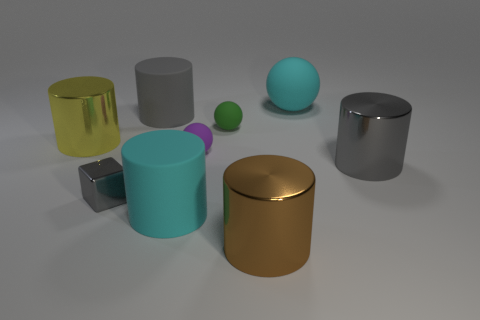The brown thing that is the same size as the yellow object is what shape?
Provide a short and direct response. Cylinder. Is the number of large gray rubber things less than the number of big yellow matte blocks?
Provide a succinct answer. No. There is a big cyan rubber thing that is in front of the cube; is there a tiny green sphere that is in front of it?
Your answer should be compact. No. There is a green thing that is the same material as the large sphere; what is its shape?
Make the answer very short. Sphere. Are there any other things that are the same color as the tiny shiny thing?
Provide a succinct answer. Yes. What material is the cyan thing that is the same shape as the green rubber object?
Your answer should be compact. Rubber. How many other objects are there of the same size as the yellow shiny cylinder?
Your answer should be very brief. 5. There is a tiny matte thing that is behind the yellow cylinder; is it the same shape as the brown shiny object?
Make the answer very short. No. What number of other things are there of the same shape as the small purple thing?
Provide a short and direct response. 2. There is a big cyan matte thing that is behind the gray matte object; what shape is it?
Offer a terse response. Sphere. 